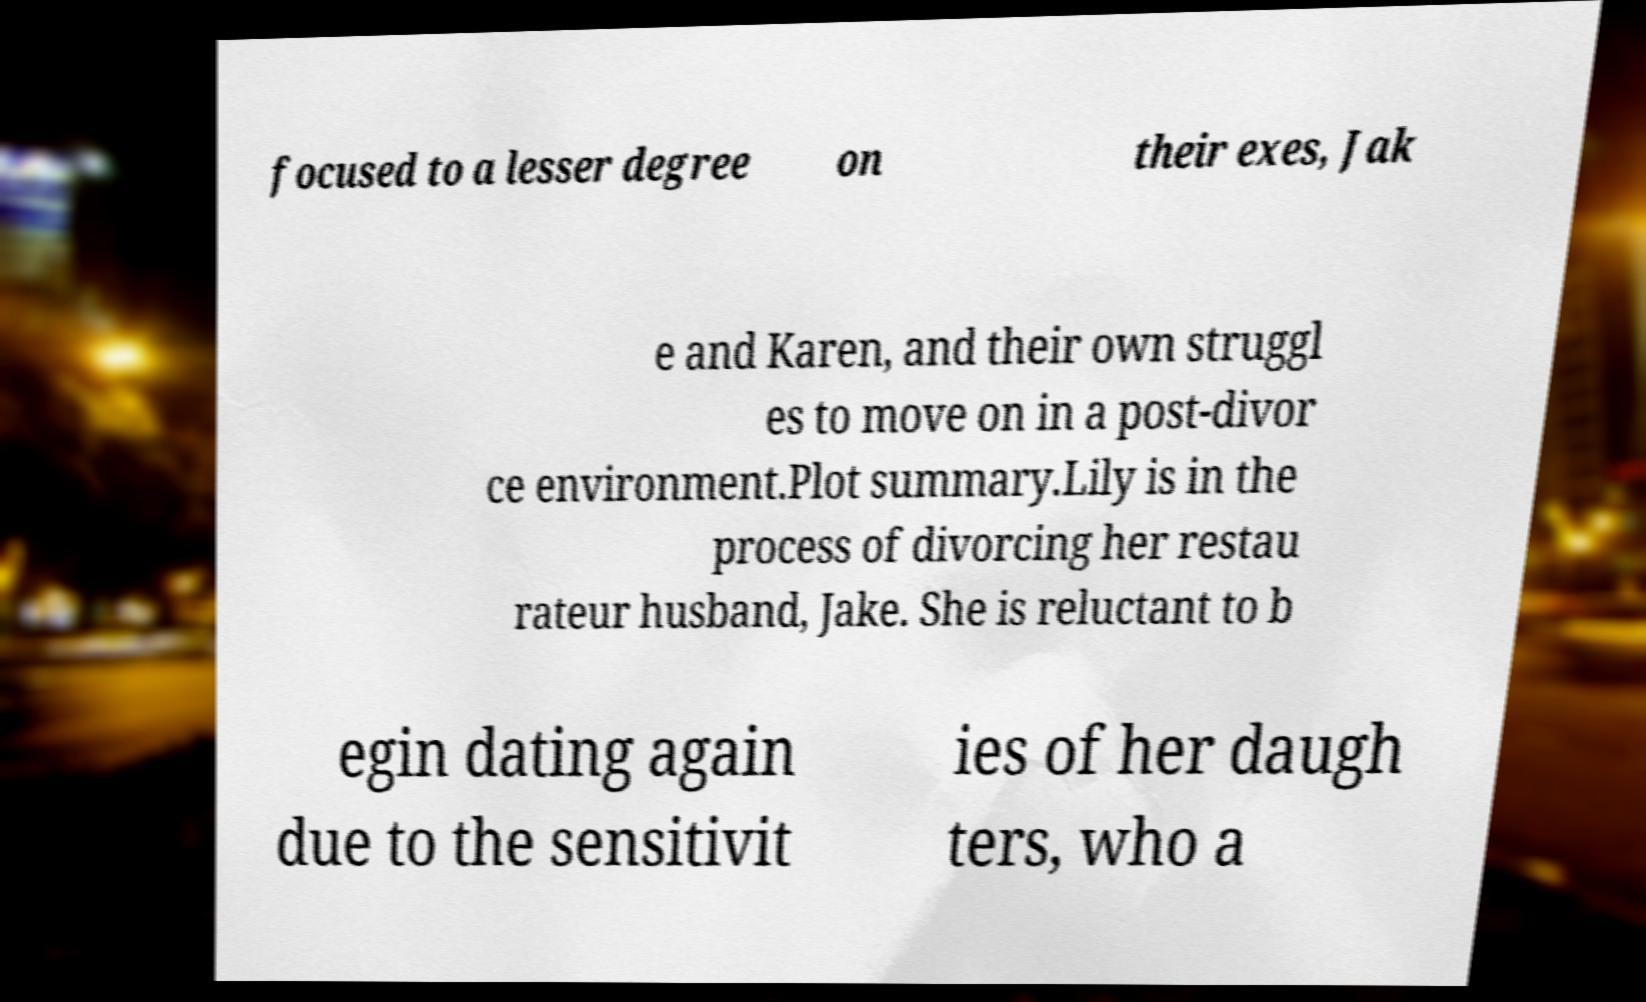Please identify and transcribe the text found in this image. focused to a lesser degree on their exes, Jak e and Karen, and their own struggl es to move on in a post-divor ce environment.Plot summary.Lily is in the process of divorcing her restau rateur husband, Jake. She is reluctant to b egin dating again due to the sensitivit ies of her daugh ters, who a 